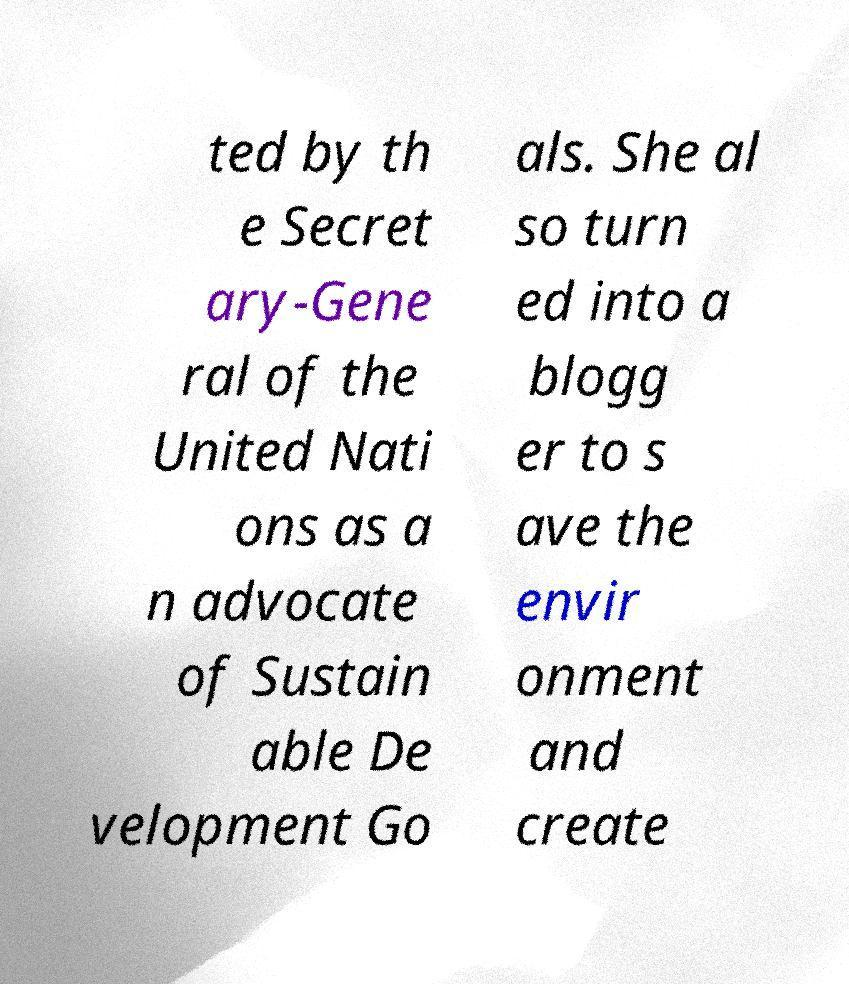Please read and relay the text visible in this image. What does it say? ted by th e Secret ary-Gene ral of the United Nati ons as a n advocate of Sustain able De velopment Go als. She al so turn ed into a blogg er to s ave the envir onment and create 